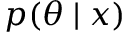<formula> <loc_0><loc_0><loc_500><loc_500>p ( \theta | x )</formula> 